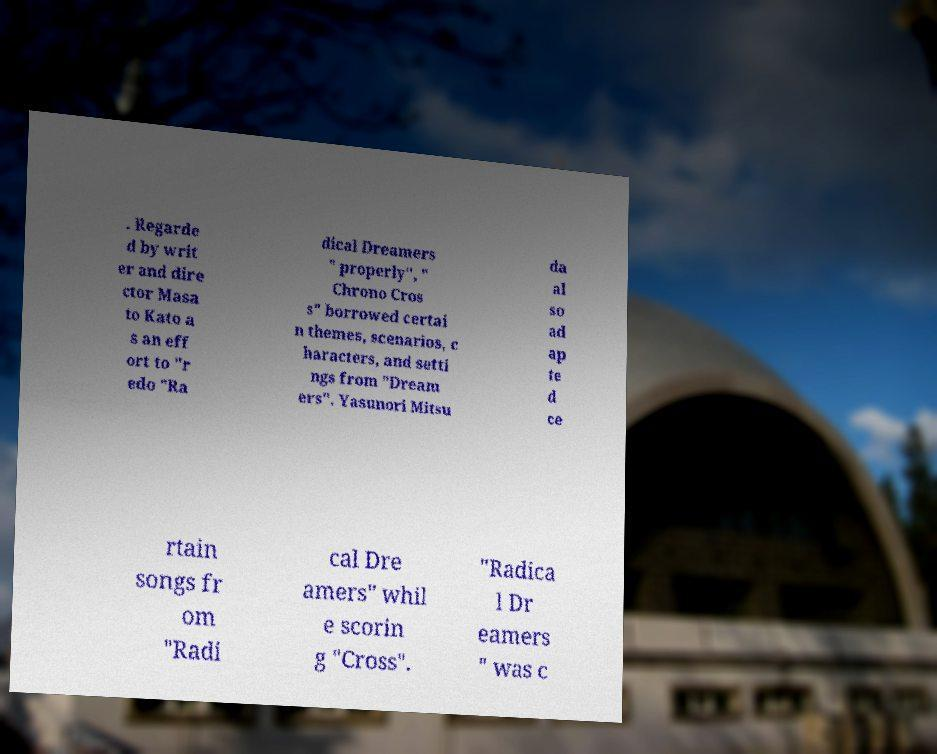Can you accurately transcribe the text from the provided image for me? . Regarde d by writ er and dire ctor Masa to Kato a s an eff ort to "r edo "Ra dical Dreamers " properly", " Chrono Cros s" borrowed certai n themes, scenarios, c haracters, and setti ngs from "Dream ers". Yasunori Mitsu da al so ad ap te d ce rtain songs fr om "Radi cal Dre amers" whil e scorin g "Cross". "Radica l Dr eamers " was c 